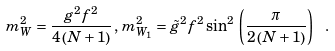Convert formula to latex. <formula><loc_0><loc_0><loc_500><loc_500>m _ { W } ^ { 2 } = \frac { g ^ { 2 } f ^ { 2 } } { { 4 \left ( { N + 1 } \right ) } } \, , \, m _ { W _ { 1 } } ^ { 2 } = \tilde { g } ^ { 2 } f ^ { 2 } \sin ^ { 2 } \, \left ( { \frac { \pi } { { 2 \left ( { N + 1 } \right ) } } } \right ) \ .</formula> 